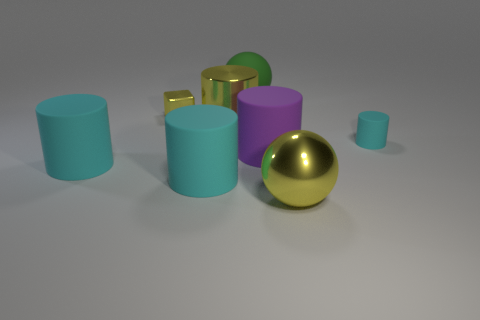How many large things are gray shiny blocks or matte spheres?
Offer a very short reply. 1. Are there any big objects that are right of the big rubber object behind the big metal cylinder?
Your answer should be very brief. Yes. Are any yellow cylinders visible?
Make the answer very short. Yes. What color is the large rubber cylinder that is to the right of the sphere behind the small cyan rubber thing?
Your answer should be compact. Purple. There is a large purple thing that is the same shape as the tiny cyan thing; what is it made of?
Offer a very short reply. Rubber. How many green balls are the same size as the purple rubber object?
Give a very brief answer. 1. The yellow cube that is made of the same material as the yellow ball is what size?
Your response must be concise. Small. How many large yellow objects have the same shape as the green thing?
Offer a terse response. 1. How many rubber cylinders are there?
Give a very brief answer. 4. Is the shape of the large yellow object that is in front of the small cylinder the same as  the big green thing?
Provide a short and direct response. Yes. 